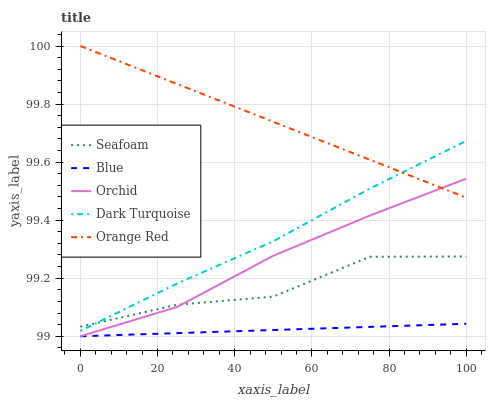Does Blue have the minimum area under the curve?
Answer yes or no. Yes. Does Orange Red have the maximum area under the curve?
Answer yes or no. Yes. Does Dark Turquoise have the minimum area under the curve?
Answer yes or no. No. Does Dark Turquoise have the maximum area under the curve?
Answer yes or no. No. Is Blue the smoothest?
Answer yes or no. Yes. Is Seafoam the roughest?
Answer yes or no. Yes. Is Dark Turquoise the smoothest?
Answer yes or no. No. Is Dark Turquoise the roughest?
Answer yes or no. No. Does Blue have the lowest value?
Answer yes or no. Yes. Does Dark Turquoise have the lowest value?
Answer yes or no. No. Does Orange Red have the highest value?
Answer yes or no. Yes. Does Dark Turquoise have the highest value?
Answer yes or no. No. Is Orchid less than Dark Turquoise?
Answer yes or no. Yes. Is Seafoam greater than Blue?
Answer yes or no. Yes. Does Dark Turquoise intersect Orange Red?
Answer yes or no. Yes. Is Dark Turquoise less than Orange Red?
Answer yes or no. No. Is Dark Turquoise greater than Orange Red?
Answer yes or no. No. Does Orchid intersect Dark Turquoise?
Answer yes or no. No. 